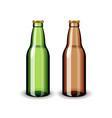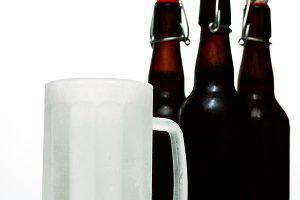The first image is the image on the left, the second image is the image on the right. Analyze the images presented: Is the assertion "There is exactly one green bottle in one of the images." valid? Answer yes or no. Yes. The first image is the image on the left, the second image is the image on the right. Given the left and right images, does the statement "In one image there is one green bottle with one brown bottle" hold true? Answer yes or no. Yes. The first image is the image on the left, the second image is the image on the right. Considering the images on both sides, is "An image shows exactly two bottles, one of them green." valid? Answer yes or no. Yes. The first image is the image on the left, the second image is the image on the right. Considering the images on both sides, is "There is a green bottle in one of the images." valid? Answer yes or no. Yes. 